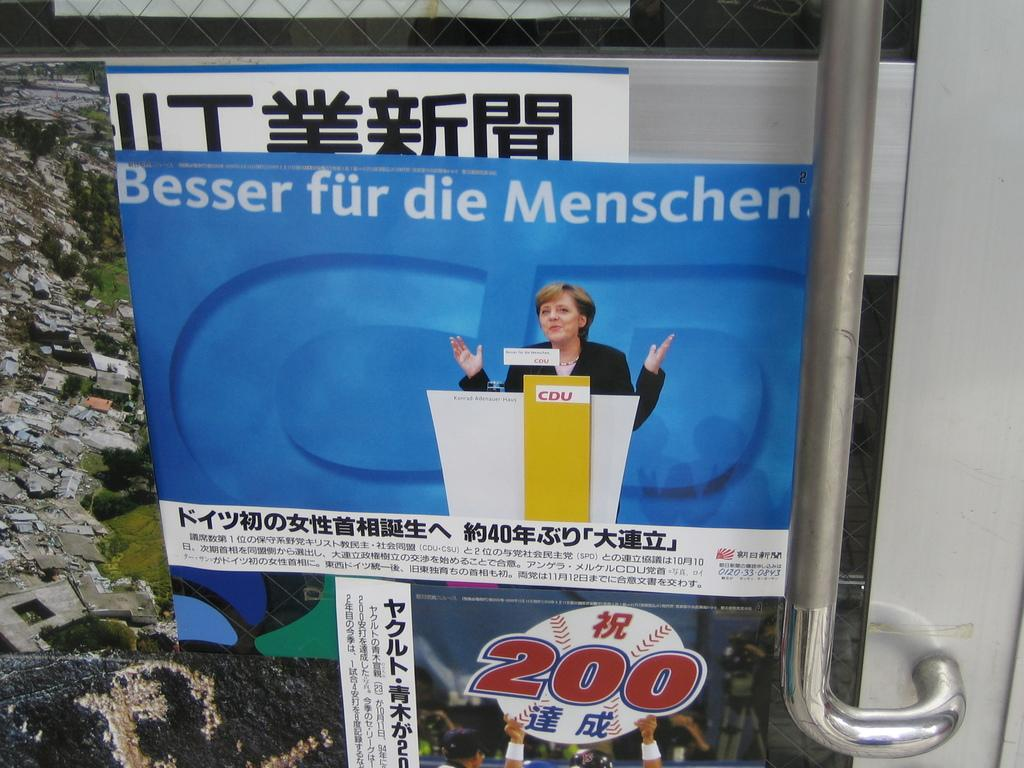<image>
Present a compact description of the photo's key features. An Asian language poster contains a baseball image with the number 200 over it. 